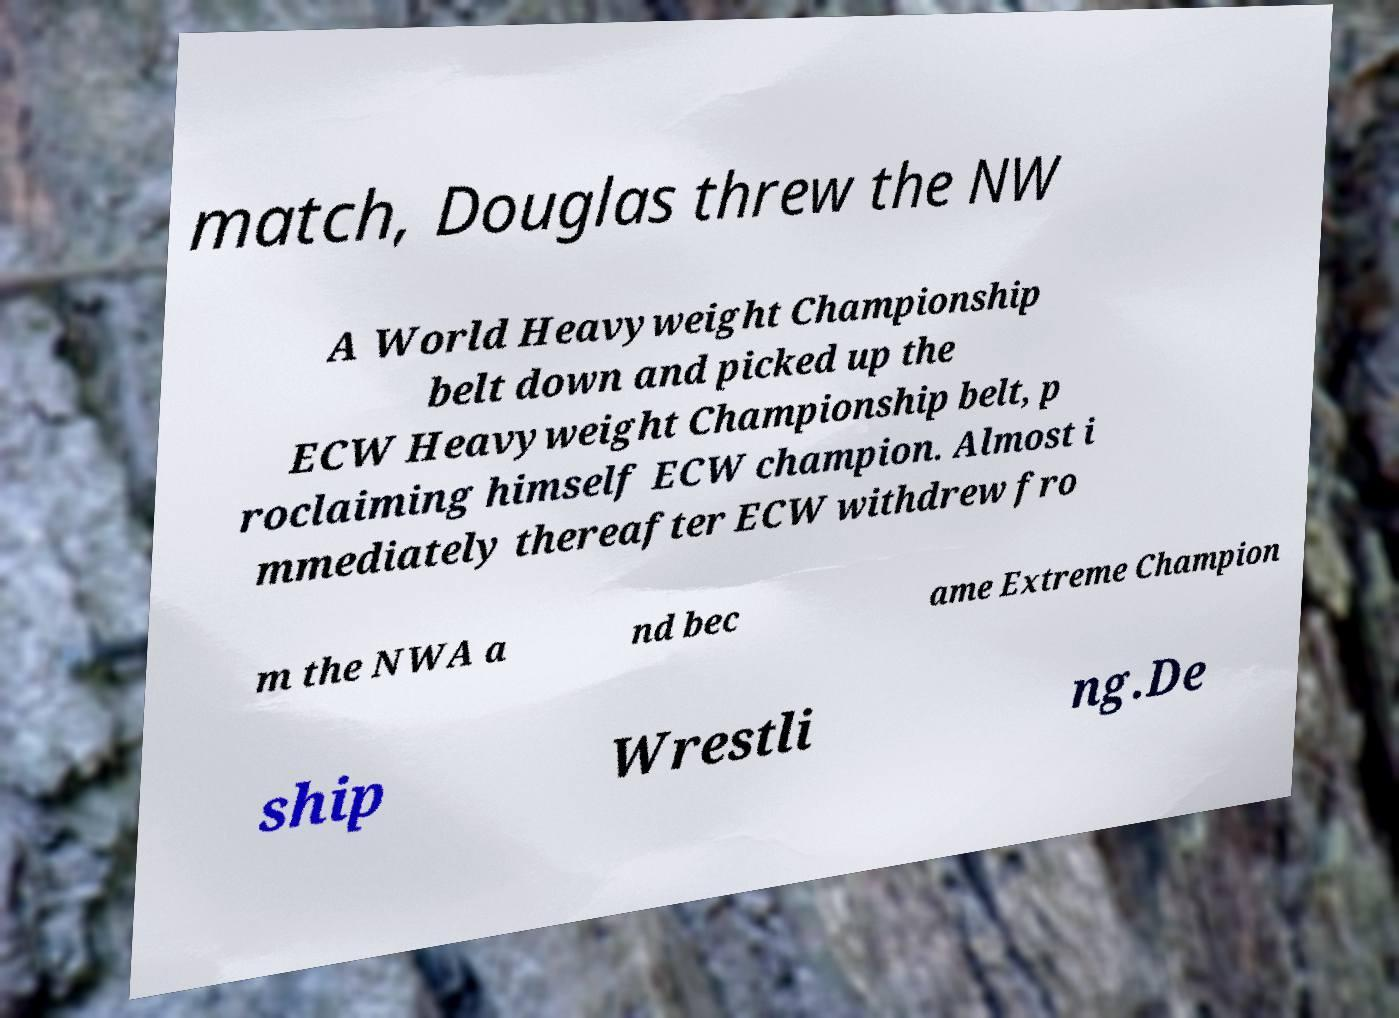For documentation purposes, I need the text within this image transcribed. Could you provide that? match, Douglas threw the NW A World Heavyweight Championship belt down and picked up the ECW Heavyweight Championship belt, p roclaiming himself ECW champion. Almost i mmediately thereafter ECW withdrew fro m the NWA a nd bec ame Extreme Champion ship Wrestli ng.De 